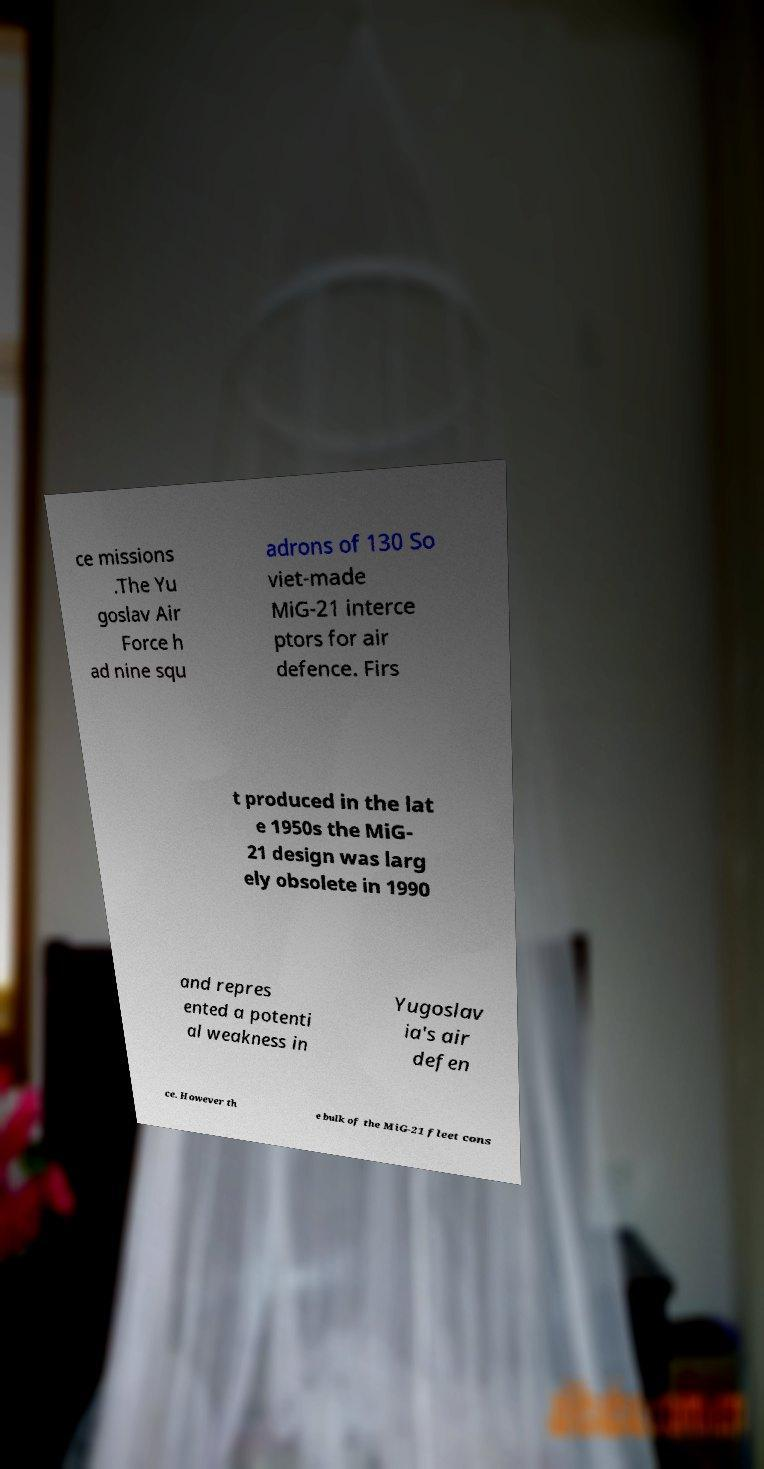Can you accurately transcribe the text from the provided image for me? ce missions .The Yu goslav Air Force h ad nine squ adrons of 130 So viet-made MiG-21 interce ptors for air defence. Firs t produced in the lat e 1950s the MiG- 21 design was larg ely obsolete in 1990 and repres ented a potenti al weakness in Yugoslav ia's air defen ce. However th e bulk of the MiG-21 fleet cons 